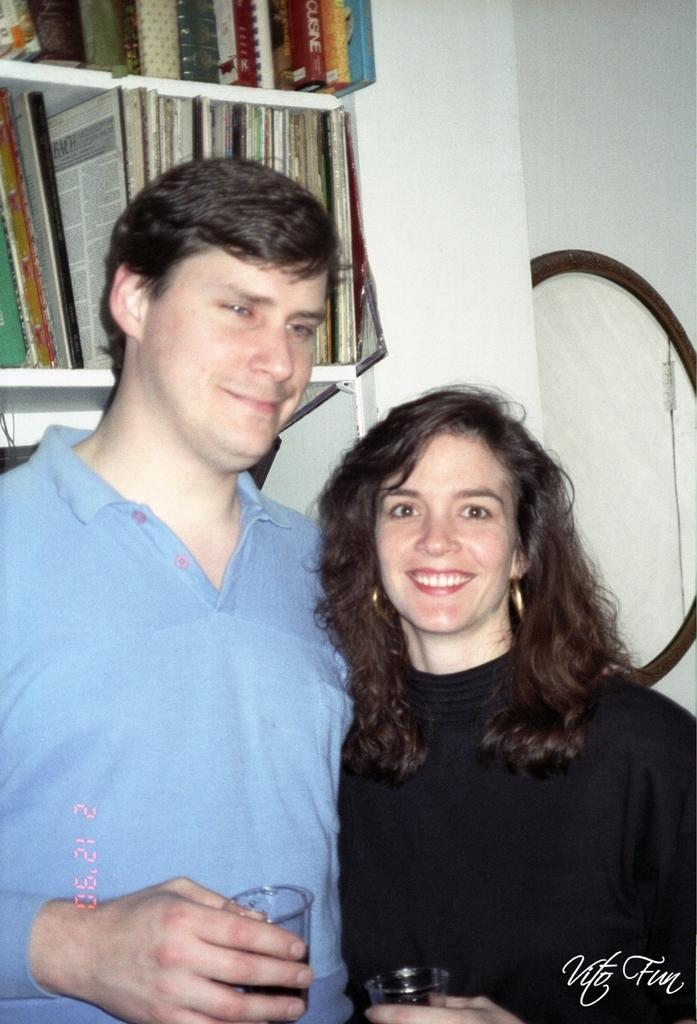Who is present in the image? There is a couple in the image. What are the couple holding in their hands? The couple is holding glasses. What can be seen in the background of the image? There are racks with books in the background. What is on the right side of the image? There is a mirror on the right side of the image. What type of finger can be seen in the image? There is no finger present in the image. What appliance is visible in the image? There is no appliance visible in the image. 